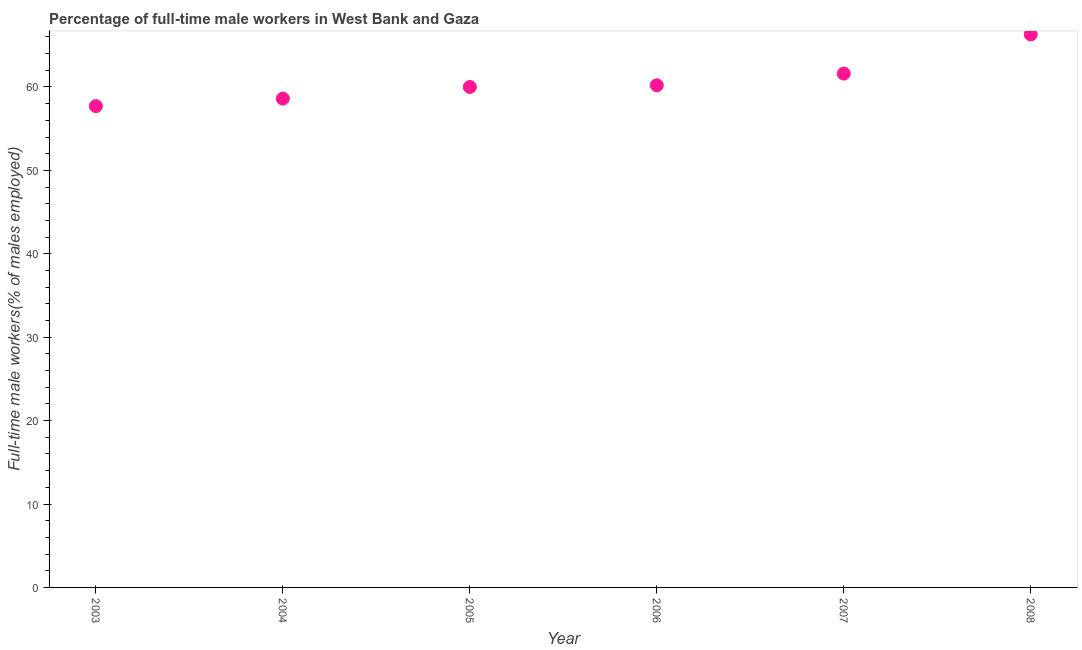What is the percentage of full-time male workers in 2008?
Offer a very short reply. 66.3. Across all years, what is the maximum percentage of full-time male workers?
Provide a succinct answer. 66.3. Across all years, what is the minimum percentage of full-time male workers?
Provide a succinct answer. 57.7. In which year was the percentage of full-time male workers maximum?
Your response must be concise. 2008. What is the sum of the percentage of full-time male workers?
Provide a succinct answer. 364.4. What is the difference between the percentage of full-time male workers in 2003 and 2004?
Ensure brevity in your answer.  -0.9. What is the average percentage of full-time male workers per year?
Your answer should be compact. 60.73. What is the median percentage of full-time male workers?
Offer a terse response. 60.1. Do a majority of the years between 2005 and 2003 (inclusive) have percentage of full-time male workers greater than 44 %?
Give a very brief answer. No. What is the ratio of the percentage of full-time male workers in 2004 to that in 2007?
Give a very brief answer. 0.95. Is the difference between the percentage of full-time male workers in 2004 and 2005 greater than the difference between any two years?
Your answer should be very brief. No. What is the difference between the highest and the second highest percentage of full-time male workers?
Offer a terse response. 4.7. What is the difference between the highest and the lowest percentage of full-time male workers?
Your answer should be very brief. 8.6. In how many years, is the percentage of full-time male workers greater than the average percentage of full-time male workers taken over all years?
Offer a very short reply. 2. What is the difference between two consecutive major ticks on the Y-axis?
Ensure brevity in your answer.  10. Are the values on the major ticks of Y-axis written in scientific E-notation?
Your answer should be very brief. No. What is the title of the graph?
Provide a short and direct response. Percentage of full-time male workers in West Bank and Gaza. What is the label or title of the Y-axis?
Provide a short and direct response. Full-time male workers(% of males employed). What is the Full-time male workers(% of males employed) in 2003?
Ensure brevity in your answer.  57.7. What is the Full-time male workers(% of males employed) in 2004?
Ensure brevity in your answer.  58.6. What is the Full-time male workers(% of males employed) in 2006?
Keep it short and to the point. 60.2. What is the Full-time male workers(% of males employed) in 2007?
Ensure brevity in your answer.  61.6. What is the Full-time male workers(% of males employed) in 2008?
Your answer should be compact. 66.3. What is the difference between the Full-time male workers(% of males employed) in 2003 and 2006?
Your answer should be compact. -2.5. What is the difference between the Full-time male workers(% of males employed) in 2004 and 2006?
Your answer should be compact. -1.6. What is the difference between the Full-time male workers(% of males employed) in 2004 and 2008?
Your answer should be very brief. -7.7. What is the difference between the Full-time male workers(% of males employed) in 2005 and 2006?
Offer a terse response. -0.2. What is the difference between the Full-time male workers(% of males employed) in 2005 and 2007?
Offer a terse response. -1.6. What is the ratio of the Full-time male workers(% of males employed) in 2003 to that in 2005?
Your response must be concise. 0.96. What is the ratio of the Full-time male workers(% of males employed) in 2003 to that in 2006?
Keep it short and to the point. 0.96. What is the ratio of the Full-time male workers(% of males employed) in 2003 to that in 2007?
Your response must be concise. 0.94. What is the ratio of the Full-time male workers(% of males employed) in 2003 to that in 2008?
Ensure brevity in your answer.  0.87. What is the ratio of the Full-time male workers(% of males employed) in 2004 to that in 2005?
Give a very brief answer. 0.98. What is the ratio of the Full-time male workers(% of males employed) in 2004 to that in 2006?
Provide a succinct answer. 0.97. What is the ratio of the Full-time male workers(% of males employed) in 2004 to that in 2007?
Keep it short and to the point. 0.95. What is the ratio of the Full-time male workers(% of males employed) in 2004 to that in 2008?
Your answer should be compact. 0.88. What is the ratio of the Full-time male workers(% of males employed) in 2005 to that in 2006?
Give a very brief answer. 1. What is the ratio of the Full-time male workers(% of males employed) in 2005 to that in 2008?
Keep it short and to the point. 0.91. What is the ratio of the Full-time male workers(% of males employed) in 2006 to that in 2007?
Ensure brevity in your answer.  0.98. What is the ratio of the Full-time male workers(% of males employed) in 2006 to that in 2008?
Make the answer very short. 0.91. What is the ratio of the Full-time male workers(% of males employed) in 2007 to that in 2008?
Ensure brevity in your answer.  0.93. 